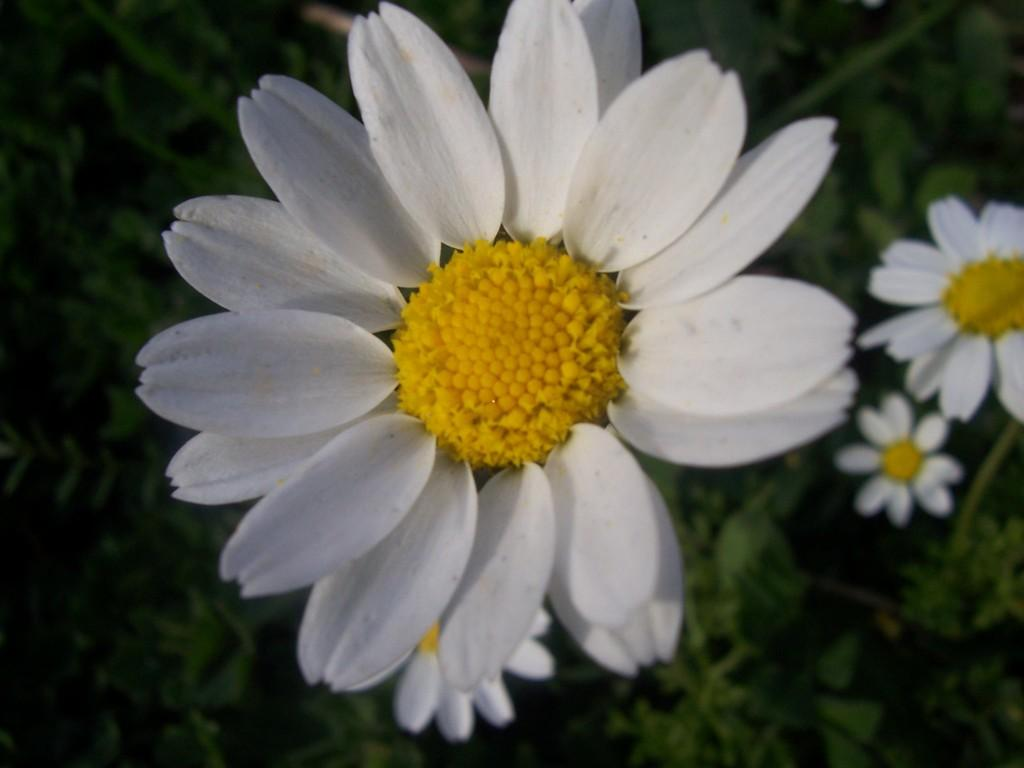What type of flowers are present in the image? There are white flowers in the image. What color is the background of the image? The background of the image is green. Can you see a river flowing through the white flowers in the image? There is no river present in the image; it only features white flowers against a green background. How many feet are visible in the image? There are no feet visible in the image. 